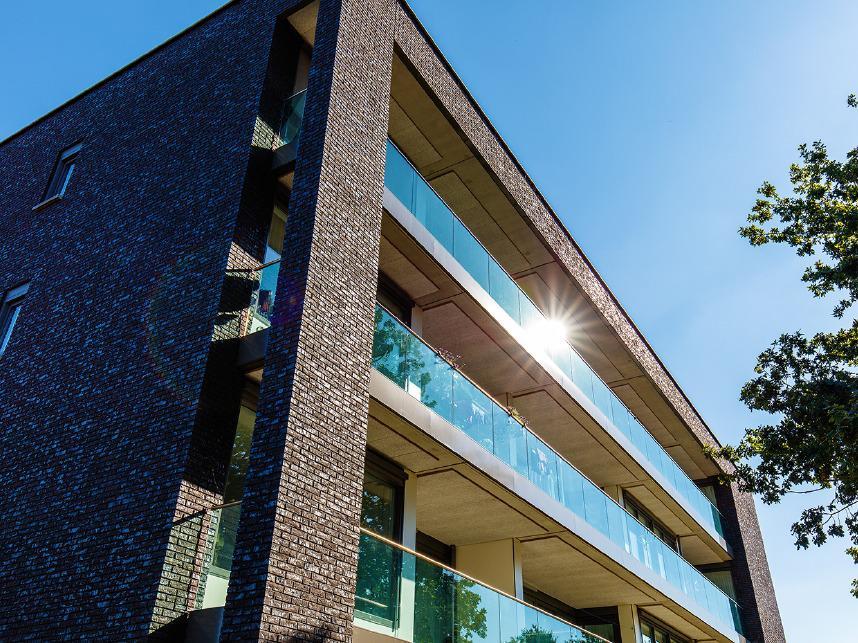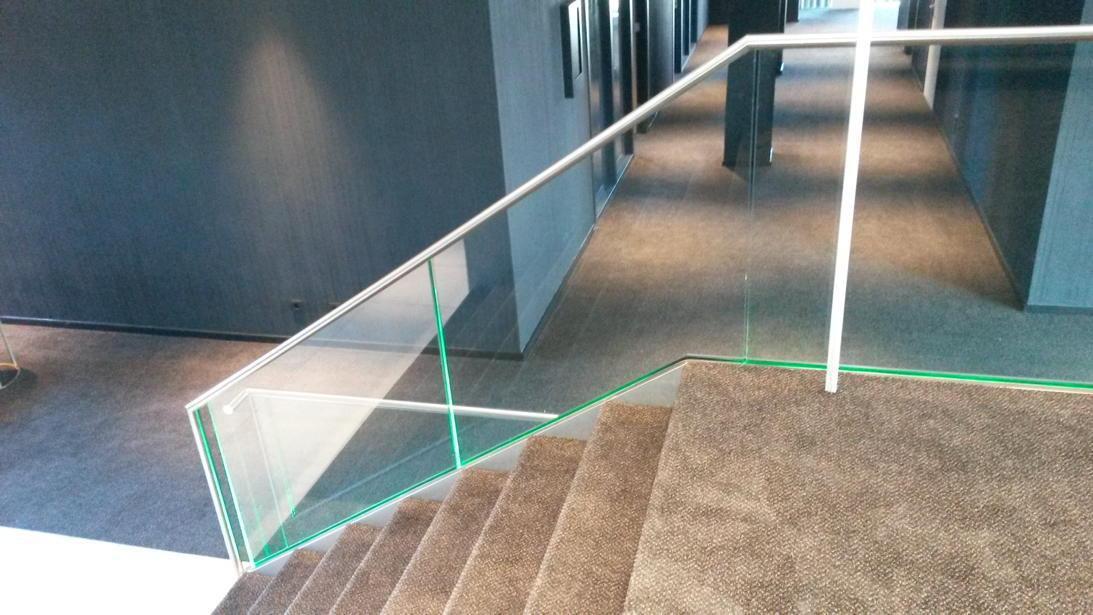The first image is the image on the left, the second image is the image on the right. Analyze the images presented: Is the assertion "The left image is an upward view of a white-framed balcony with glass panels instead of rails in front of paned glass windows." valid? Answer yes or no. No. The first image is the image on the left, the second image is the image on the right. Examine the images to the left and right. Is the description "The left image features the exterior of a building and the right image features the interior of a building." accurate? Answer yes or no. Yes. 